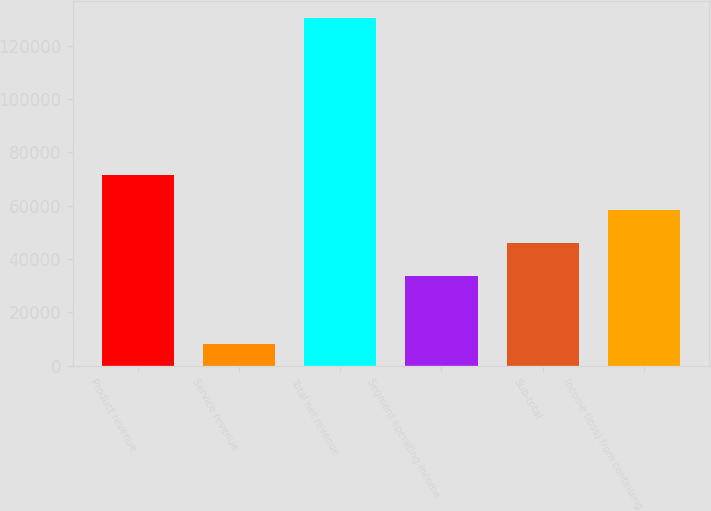<chart> <loc_0><loc_0><loc_500><loc_500><bar_chart><fcel>Product revenue<fcel>Service revenue<fcel>Total net revenue<fcel>Segment operating income<fcel>Sub-total<fcel>Income (loss) from continuing<nl><fcel>71567<fcel>8035<fcel>130285<fcel>33856<fcel>46081<fcel>58306<nl></chart> 